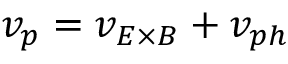<formula> <loc_0><loc_0><loc_500><loc_500>v _ { p } = v _ { E \times B } + v _ { p h }</formula> 